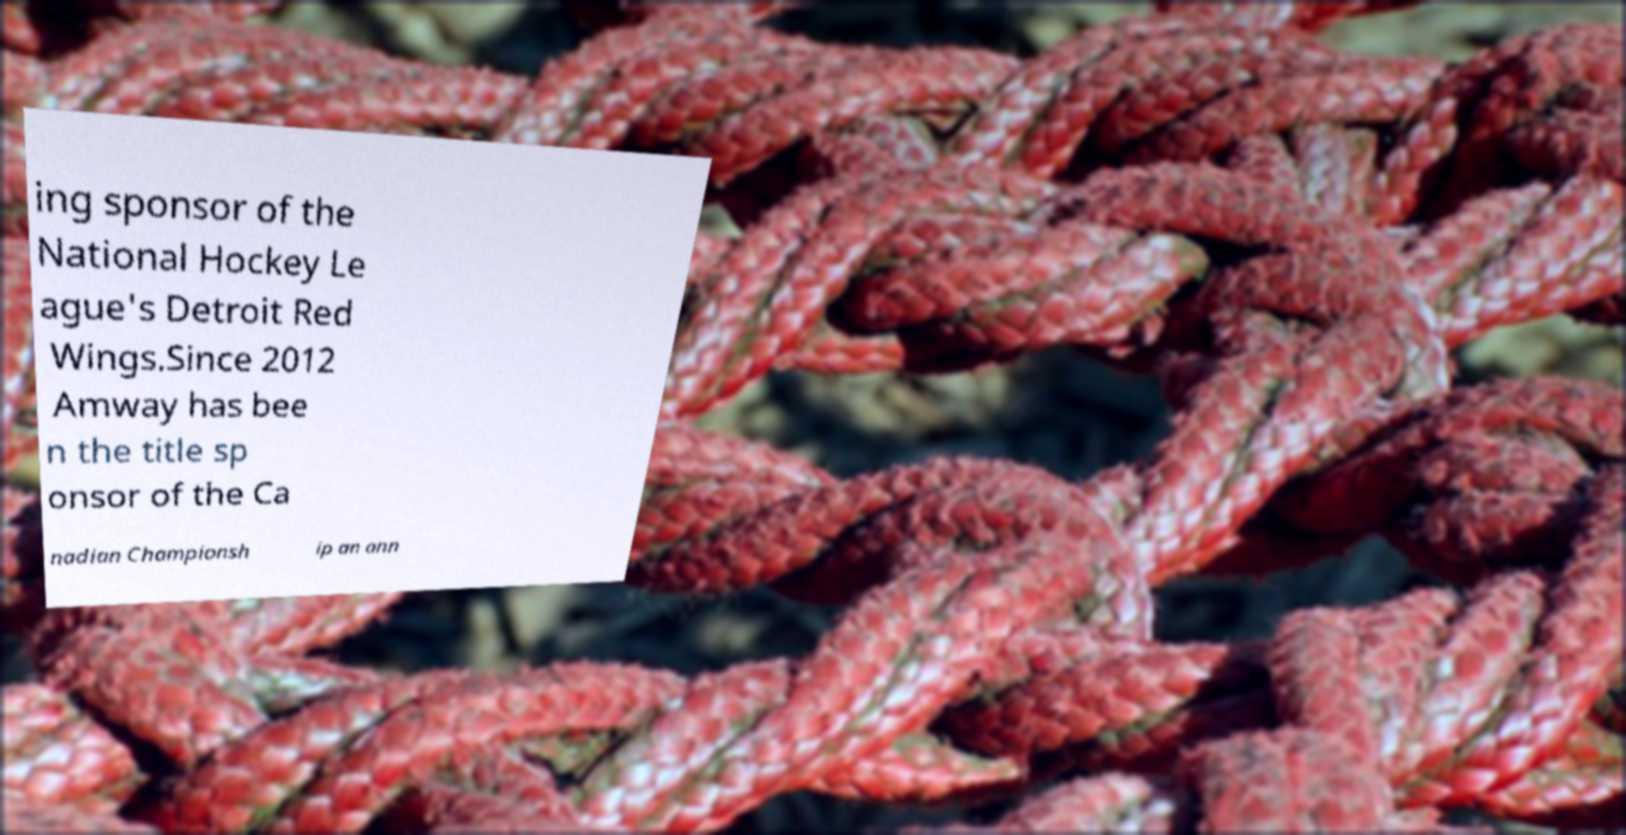Can you read and provide the text displayed in the image?This photo seems to have some interesting text. Can you extract and type it out for me? ing sponsor of the National Hockey Le ague's Detroit Red Wings.Since 2012 Amway has bee n the title sp onsor of the Ca nadian Championsh ip an ann 